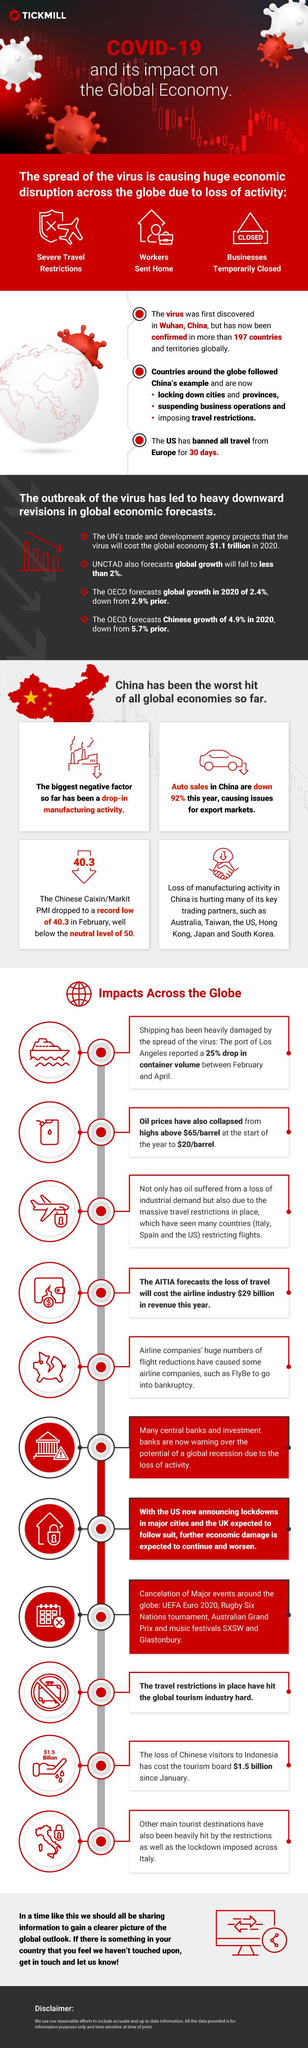Identify some key points in this picture. The container volume dropped by 25% in three months. The Caixin/Markit PMI in China has dropped significantly from its neutral level of 9.7, indicating a decline in the health of the country's manufacturing sector. The oil price per barrel has been reduced by a significant amount of dollars. 